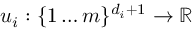<formula> <loc_0><loc_0><loc_500><loc_500>u _ { i } \colon \{ 1 \dots m \} ^ { d _ { i } + 1 } \rightarrow \mathbb { R }</formula> 